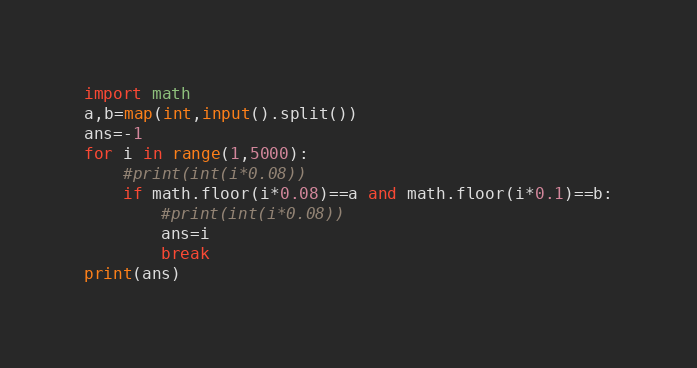<code> <loc_0><loc_0><loc_500><loc_500><_Python_>import math
a,b=map(int,input().split())
ans=-1
for i in range(1,5000):
    #print(int(i*0.08))
    if math.floor(i*0.08)==a and math.floor(i*0.1)==b:
        #print(int(i*0.08))
        ans=i
        break
print(ans)</code> 